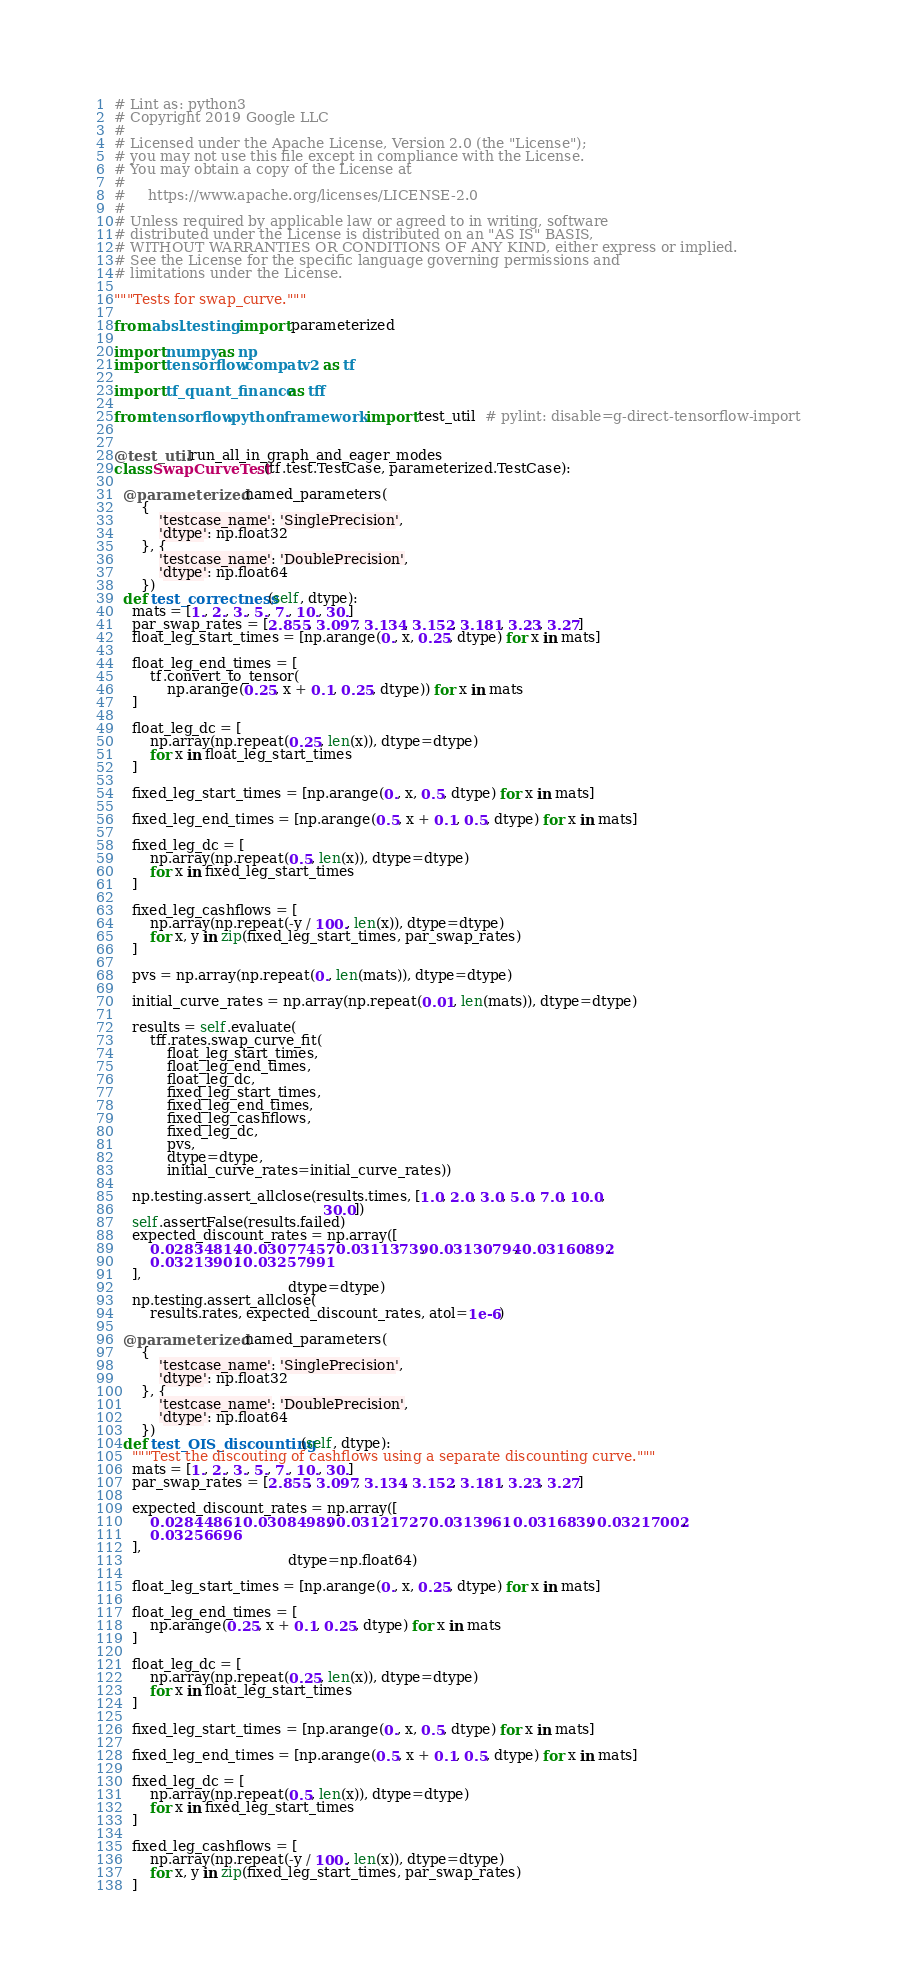Convert code to text. <code><loc_0><loc_0><loc_500><loc_500><_Python_># Lint as: python3
# Copyright 2019 Google LLC
#
# Licensed under the Apache License, Version 2.0 (the "License");
# you may not use this file except in compliance with the License.
# You may obtain a copy of the License at
#
#     https://www.apache.org/licenses/LICENSE-2.0
#
# Unless required by applicable law or agreed to in writing, software
# distributed under the License is distributed on an "AS IS" BASIS,
# WITHOUT WARRANTIES OR CONDITIONS OF ANY KIND, either express or implied.
# See the License for the specific language governing permissions and
# limitations under the License.

"""Tests for swap_curve."""

from absl.testing import parameterized

import numpy as np
import tensorflow.compat.v2 as tf

import tf_quant_finance as tff

from tensorflow.python.framework import test_util  # pylint: disable=g-direct-tensorflow-import


@test_util.run_all_in_graph_and_eager_modes
class SwapCurveTest(tf.test.TestCase, parameterized.TestCase):

  @parameterized.named_parameters(
      {
          'testcase_name': 'SinglePrecision',
          'dtype': np.float32
      }, {
          'testcase_name': 'DoublePrecision',
          'dtype': np.float64
      })
  def test_correctness(self, dtype):
    mats = [1., 2., 3., 5., 7., 10., 30.]
    par_swap_rates = [2.855, 3.097, 3.134, 3.152, 3.181, 3.23, 3.27]
    float_leg_start_times = [np.arange(0., x, 0.25, dtype) for x in mats]

    float_leg_end_times = [
        tf.convert_to_tensor(
            np.arange(0.25, x + 0.1, 0.25, dtype)) for x in mats
    ]

    float_leg_dc = [
        np.array(np.repeat(0.25, len(x)), dtype=dtype)
        for x in float_leg_start_times
    ]

    fixed_leg_start_times = [np.arange(0., x, 0.5, dtype) for x in mats]

    fixed_leg_end_times = [np.arange(0.5, x + 0.1, 0.5, dtype) for x in mats]

    fixed_leg_dc = [
        np.array(np.repeat(0.5, len(x)), dtype=dtype)
        for x in fixed_leg_start_times
    ]

    fixed_leg_cashflows = [
        np.array(np.repeat(-y / 100., len(x)), dtype=dtype)
        for x, y in zip(fixed_leg_start_times, par_swap_rates)
    ]

    pvs = np.array(np.repeat(0., len(mats)), dtype=dtype)

    initial_curve_rates = np.array(np.repeat(0.01, len(mats)), dtype=dtype)

    results = self.evaluate(
        tff.rates.swap_curve_fit(
            float_leg_start_times,
            float_leg_end_times,
            float_leg_dc,
            fixed_leg_start_times,
            fixed_leg_end_times,
            fixed_leg_cashflows,
            fixed_leg_dc,
            pvs,
            dtype=dtype,
            initial_curve_rates=initial_curve_rates))

    np.testing.assert_allclose(results.times, [1.0, 2.0, 3.0, 5.0, 7.0, 10.0,
                                               30.0])
    self.assertFalse(results.failed)
    expected_discount_rates = np.array([
        0.02834814, 0.03077457, 0.03113739, 0.03130794, 0.03160892,
        0.03213901, 0.03257991
    ],
                                       dtype=dtype)
    np.testing.assert_allclose(
        results.rates, expected_discount_rates, atol=1e-6)

  @parameterized.named_parameters(
      {
          'testcase_name': 'SinglePrecision',
          'dtype': np.float32
      }, {
          'testcase_name': 'DoublePrecision',
          'dtype': np.float64
      })
  def test_OIS_discounting(self, dtype):
    """Test the discouting of cashflows using a separate discounting curve."""
    mats = [1., 2., 3., 5., 7., 10., 30.]
    par_swap_rates = [2.855, 3.097, 3.134, 3.152, 3.181, 3.23, 3.27]

    expected_discount_rates = np.array([
        0.02844861, 0.03084989, 0.03121727, 0.0313961, 0.0316839, 0.03217002,
        0.03256696
    ],
                                       dtype=np.float64)

    float_leg_start_times = [np.arange(0., x, 0.25, dtype) for x in mats]

    float_leg_end_times = [
        np.arange(0.25, x + 0.1, 0.25, dtype) for x in mats
    ]

    float_leg_dc = [
        np.array(np.repeat(0.25, len(x)), dtype=dtype)
        for x in float_leg_start_times
    ]

    fixed_leg_start_times = [np.arange(0., x, 0.5, dtype) for x in mats]

    fixed_leg_end_times = [np.arange(0.5, x + 0.1, 0.5, dtype) for x in mats]

    fixed_leg_dc = [
        np.array(np.repeat(0.5, len(x)), dtype=dtype)
        for x in fixed_leg_start_times
    ]

    fixed_leg_cashflows = [
        np.array(np.repeat(-y / 100., len(x)), dtype=dtype)
        for x, y in zip(fixed_leg_start_times, par_swap_rates)
    ]
</code> 